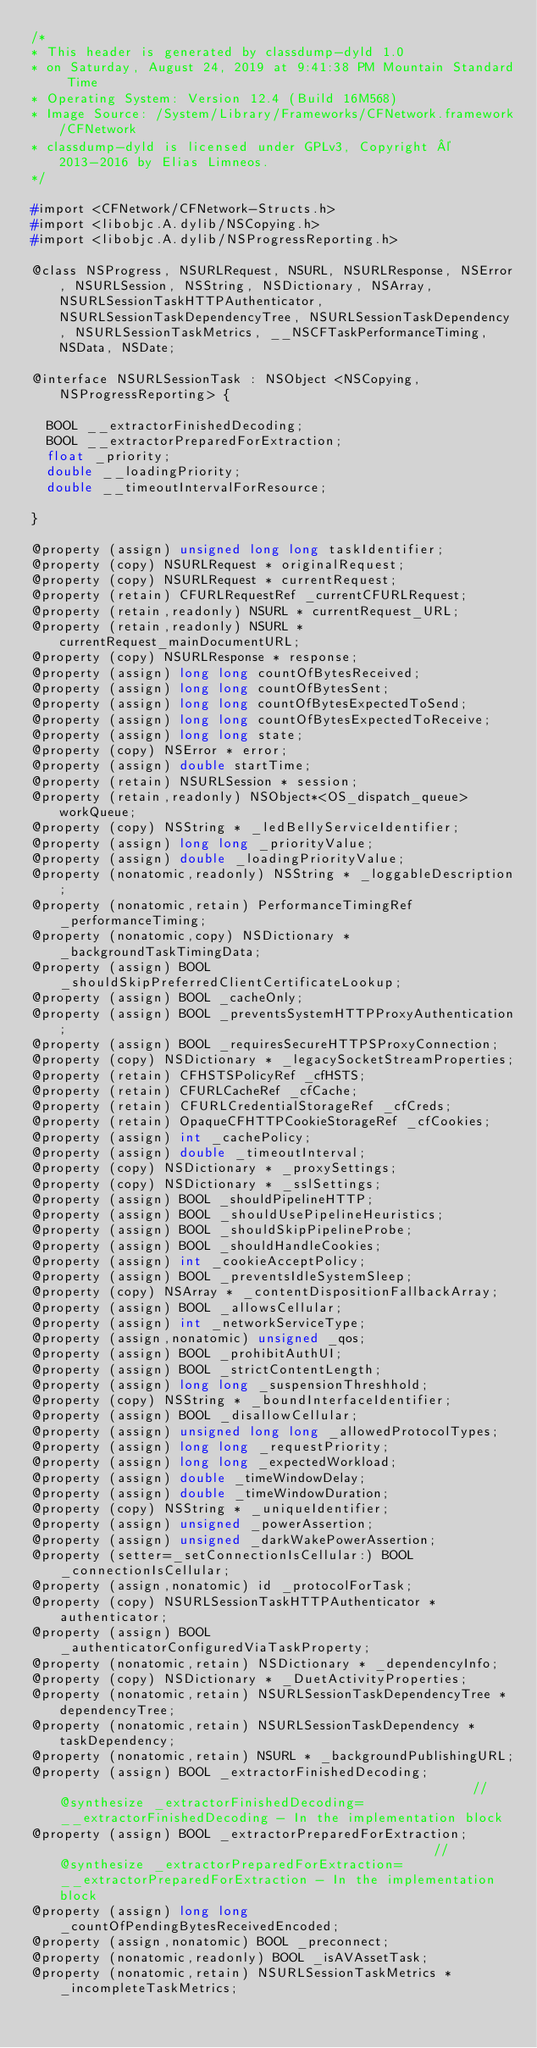Convert code to text. <code><loc_0><loc_0><loc_500><loc_500><_C_>/*
* This header is generated by classdump-dyld 1.0
* on Saturday, August 24, 2019 at 9:41:38 PM Mountain Standard Time
* Operating System: Version 12.4 (Build 16M568)
* Image Source: /System/Library/Frameworks/CFNetwork.framework/CFNetwork
* classdump-dyld is licensed under GPLv3, Copyright © 2013-2016 by Elias Limneos.
*/

#import <CFNetwork/CFNetwork-Structs.h>
#import <libobjc.A.dylib/NSCopying.h>
#import <libobjc.A.dylib/NSProgressReporting.h>

@class NSProgress, NSURLRequest, NSURL, NSURLResponse, NSError, NSURLSession, NSString, NSDictionary, NSArray, NSURLSessionTaskHTTPAuthenticator, NSURLSessionTaskDependencyTree, NSURLSessionTaskDependency, NSURLSessionTaskMetrics, __NSCFTaskPerformanceTiming, NSData, NSDate;

@interface NSURLSessionTask : NSObject <NSCopying, NSProgressReporting> {

	BOOL __extractorFinishedDecoding;
	BOOL __extractorPreparedForExtraction;
	float _priority;
	double __loadingPriority;
	double __timeoutIntervalForResource;

}

@property (assign) unsigned long long taskIdentifier; 
@property (copy) NSURLRequest * originalRequest; 
@property (copy) NSURLRequest * currentRequest; 
@property (retain) CFURLRequestRef _currentCFURLRequest; 
@property (retain,readonly) NSURL * currentRequest_URL; 
@property (retain,readonly) NSURL * currentRequest_mainDocumentURL; 
@property (copy) NSURLResponse * response; 
@property (assign) long long countOfBytesReceived; 
@property (assign) long long countOfBytesSent; 
@property (assign) long long countOfBytesExpectedToSend; 
@property (assign) long long countOfBytesExpectedToReceive; 
@property (assign) long long state; 
@property (copy) NSError * error; 
@property (assign) double startTime; 
@property (retain) NSURLSession * session; 
@property (retain,readonly) NSObject*<OS_dispatch_queue> workQueue; 
@property (copy) NSString * _ledBellyServiceIdentifier; 
@property (assign) long long _priorityValue; 
@property (assign) double _loadingPriorityValue; 
@property (nonatomic,readonly) NSString * _loggableDescription; 
@property (nonatomic,retain) PerformanceTimingRef _performanceTiming; 
@property (nonatomic,copy) NSDictionary * _backgroundTaskTimingData; 
@property (assign) BOOL _shouldSkipPreferredClientCertificateLookup; 
@property (assign) BOOL _cacheOnly; 
@property (assign) BOOL _preventsSystemHTTPProxyAuthentication; 
@property (assign) BOOL _requiresSecureHTTPSProxyConnection; 
@property (copy) NSDictionary * _legacySocketStreamProperties; 
@property (retain) CFHSTSPolicyRef _cfHSTS; 
@property (retain) CFURLCacheRef _cfCache; 
@property (retain) CFURLCredentialStorageRef _cfCreds; 
@property (retain) OpaqueCFHTTPCookieStorageRef _cfCookies; 
@property (assign) int _cachePolicy; 
@property (assign) double _timeoutInterval; 
@property (copy) NSDictionary * _proxySettings; 
@property (copy) NSDictionary * _sslSettings; 
@property (assign) BOOL _shouldPipelineHTTP; 
@property (assign) BOOL _shouldUsePipelineHeuristics; 
@property (assign) BOOL _shouldSkipPipelineProbe; 
@property (assign) BOOL _shouldHandleCookies; 
@property (assign) int _cookieAcceptPolicy; 
@property (assign) BOOL _preventsIdleSystemSleep; 
@property (copy) NSArray * _contentDispositionFallbackArray; 
@property (assign) BOOL _allowsCellular; 
@property (assign) int _networkServiceType; 
@property (assign,nonatomic) unsigned _qos; 
@property (assign) BOOL _prohibitAuthUI; 
@property (assign) BOOL _strictContentLength; 
@property (assign) long long _suspensionThreshhold; 
@property (copy) NSString * _boundInterfaceIdentifier; 
@property (assign) BOOL _disallowCellular; 
@property (assign) unsigned long long _allowedProtocolTypes; 
@property (assign) long long _requestPriority; 
@property (assign) long long _expectedWorkload; 
@property (assign) double _timeWindowDelay; 
@property (assign) double _timeWindowDuration; 
@property (copy) NSString * _uniqueIdentifier; 
@property (assign) unsigned _powerAssertion; 
@property (assign) unsigned _darkWakePowerAssertion; 
@property (setter=_setConnectionIsCellular:) BOOL _connectionIsCellular; 
@property (assign,nonatomic) id _protocolForTask; 
@property (copy) NSURLSessionTaskHTTPAuthenticator * authenticator; 
@property (assign) BOOL _authenticatorConfiguredViaTaskProperty; 
@property (nonatomic,retain) NSDictionary * _dependencyInfo; 
@property (copy) NSDictionary * _DuetActivityProperties; 
@property (nonatomic,retain) NSURLSessionTaskDependencyTree * dependencyTree; 
@property (nonatomic,retain) NSURLSessionTaskDependency * taskDependency; 
@property (nonatomic,retain) NSURL * _backgroundPublishingURL; 
@property (assign) BOOL _extractorFinishedDecoding;                                                      //@synthesize _extractorFinishedDecoding=__extractorFinishedDecoding - In the implementation block
@property (assign) BOOL _extractorPreparedForExtraction;                                                 //@synthesize _extractorPreparedForExtraction=__extractorPreparedForExtraction - In the implementation block
@property (assign) long long _countOfPendingBytesReceivedEncoded; 
@property (assign,nonatomic) BOOL _preconnect; 
@property (nonatomic,readonly) BOOL _isAVAssetTask; 
@property (nonatomic,retain) NSURLSessionTaskMetrics * _incompleteTaskMetrics; </code> 